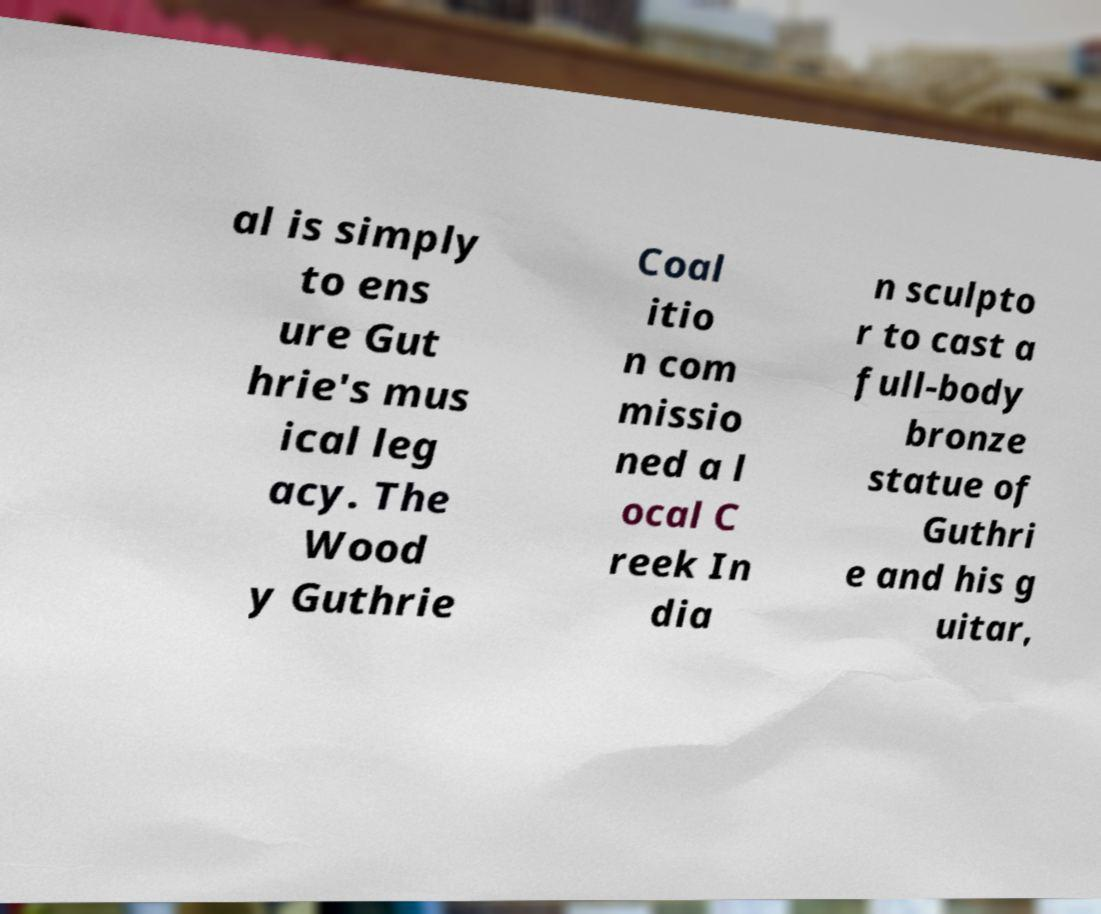For documentation purposes, I need the text within this image transcribed. Could you provide that? al is simply to ens ure Gut hrie's mus ical leg acy. The Wood y Guthrie Coal itio n com missio ned a l ocal C reek In dia n sculpto r to cast a full-body bronze statue of Guthri e and his g uitar, 